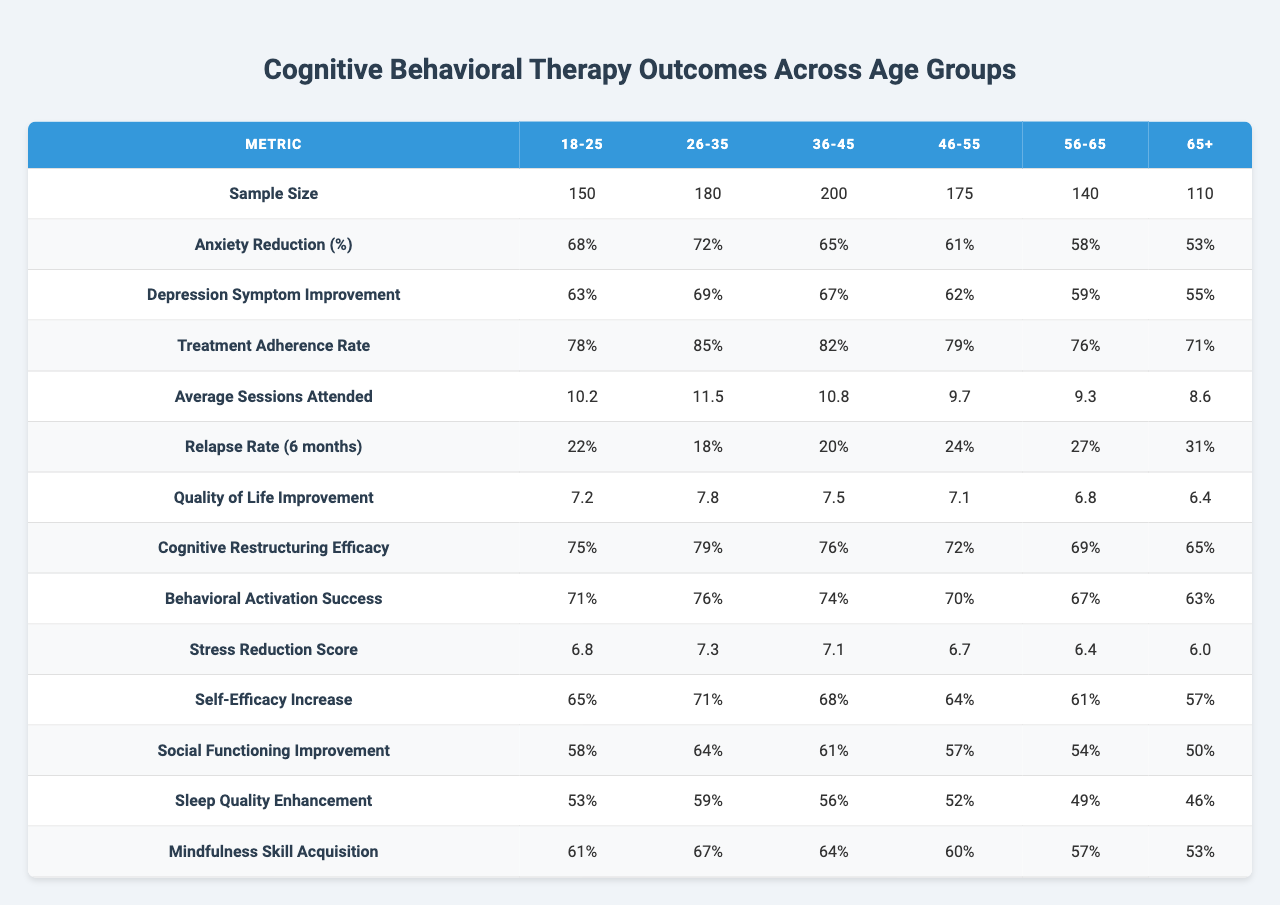What is the sample size for the age group 46-55? The table shows that the sample size for the 46-55 age group is 175.
Answer: 175 Which age group had the highest percentage of anxiety reduction? By checking the anxiety reduction percentages for all age groups, the 26-35 age group has the highest at 72%.
Answer: 72% What is the treatment adherence rate for the oldest age group (65+)? The data indicates that the treatment adherence rate for the 65+ age group is 71%.
Answer: 71% Calculate the average number of sessions attended across all age groups. To find the average, sum the number of average sessions attended (10.2 + 11.5 + 10.8 + 9.7 + 9.3 + 8.6 = 60.1) and divide by the number of age groups (60.1 / 6 ≈ 10.02).
Answer: 10.02 Is the relapse rate higher for the age group 56-65 compared to the 18-25 age group? The relapse rate is 27% for the 56-65 age group and 22% for the 18-25 age group, thus it is higher for the 56-65 age group.
Answer: Yes What is the difference in cognitive restructuring efficacy between the 18-25 and 46-55 age groups? The cognitive restructuring efficacy for the 18-25 age group is 75% and for the 46-55 age group is 72%, so the difference is 75% - 72% = 3%.
Answer: 3% Which age group showed the least improvement in quality of life? Reviewing the quality of life improvement data shows that the 65+ age group has the lowest improvement at 6.4.
Answer: 6.4 Does the average number of sessions attended decrease with increasing age? By comparing average sessions attended across age groups, the values decrease from 10.2 for 18-25 down to 8.6 for 65+, indicating a trend of decrease with increasing age.
Answer: Yes Which age group had the lowest percentage of self-efficacy increase and what was that percentage? The table reveals that the 65+ age group had the lowest self-efficacy increase at 57%.
Answer: 57% What is the quality of life improvement for the age group 36-45? The table shows that the quality of life improvement for the 36-45 age group is 7.5.
Answer: 7.5 If we average the depression symptom improvement values, what do we get? Adding the depression symptom improvement percentages (63 + 69 + 67 + 62 + 59 + 55 = 405) and dividing by the number of age groups (405 / 6 = 67.5) gives an average of 67.5.
Answer: 67.5 